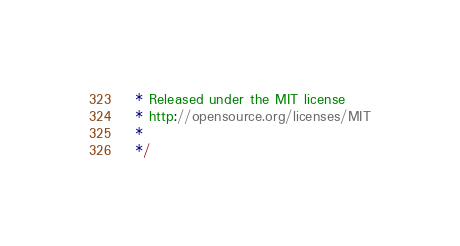<code> <loc_0><loc_0><loc_500><loc_500><_JavaScript_> * Released under the MIT license
 * http://opensource.org/licenses/MIT
 *
 */</code> 